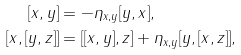Convert formula to latex. <formula><loc_0><loc_0><loc_500><loc_500>[ x , y ] & = - \eta _ { x , y } [ y , x ] , \\ [ x , [ y , z ] ] & = [ [ x , y ] , z ] + \eta _ { x , y } [ y , [ x , z ] ] ,</formula> 